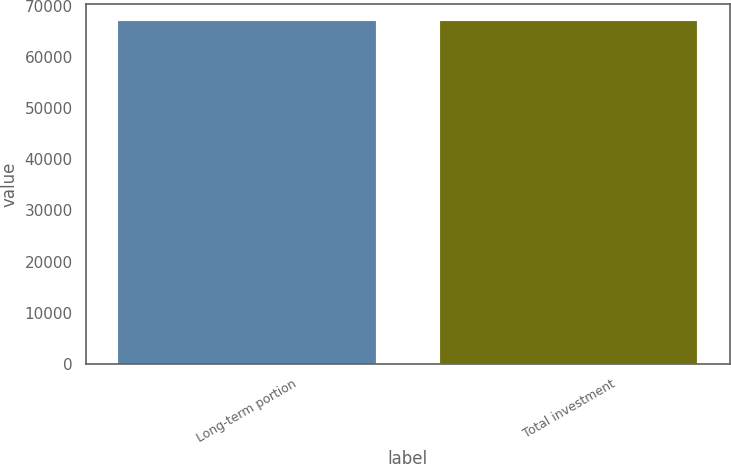<chart> <loc_0><loc_0><loc_500><loc_500><bar_chart><fcel>Long-term portion<fcel>Total investment<nl><fcel>67050<fcel>67050.1<nl></chart> 